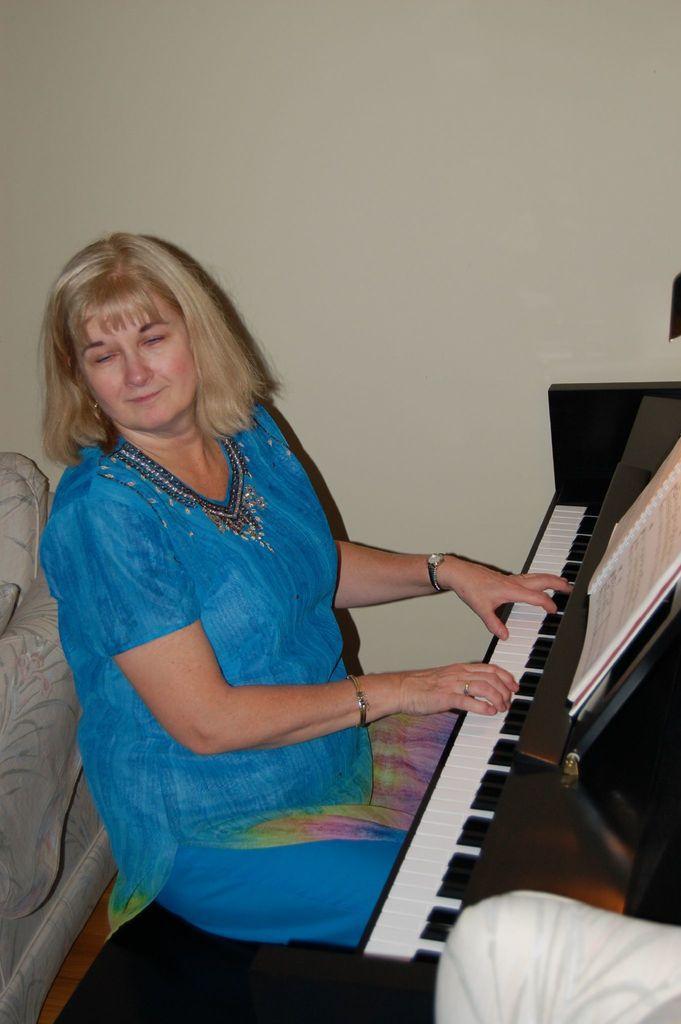Can you describe this image briefly? In this image we can see a lady wearing blue dress is sitting and playing piano. 